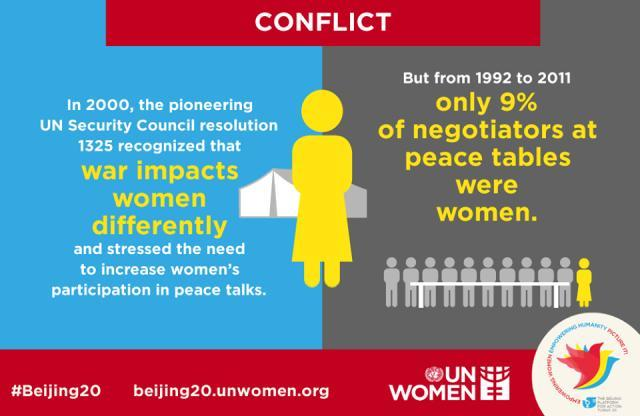what is the colour of the female shown , grey or yellow
Answer the question with a short phrase. yellow If there were 100 negotiators between 1992 to 2011, how many would have been women as per analysis made 9 which resolution stressed the need to increase women's participation in peace talks 1325 